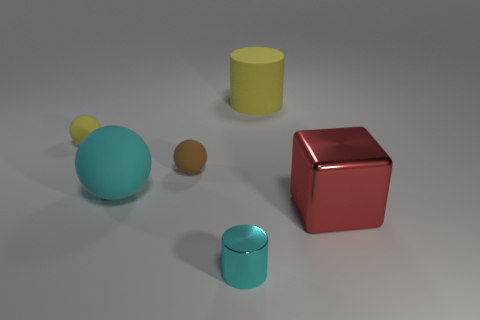Is the number of tiny brown objects that are behind the big cyan rubber ball the same as the number of brown balls?
Provide a succinct answer. Yes. Is there a big ball of the same color as the matte cylinder?
Make the answer very short. No. Does the brown sphere have the same size as the red metal cube?
Make the answer very short. No. What is the size of the cylinder that is in front of the big yellow cylinder that is on the right side of the cyan sphere?
Offer a terse response. Small. There is a object that is right of the small cyan thing and behind the big red cube; how big is it?
Your answer should be very brief. Large. How many brown matte things have the same size as the yellow matte sphere?
Offer a very short reply. 1. What number of rubber objects are blocks or small gray balls?
Keep it short and to the point. 0. There is a sphere that is the same color as the big cylinder; what is its size?
Offer a terse response. Small. The yellow object that is left of the large ball that is behind the cube is made of what material?
Offer a very short reply. Rubber. How many objects are either big metal objects or objects behind the big cyan matte object?
Your answer should be compact. 4. 